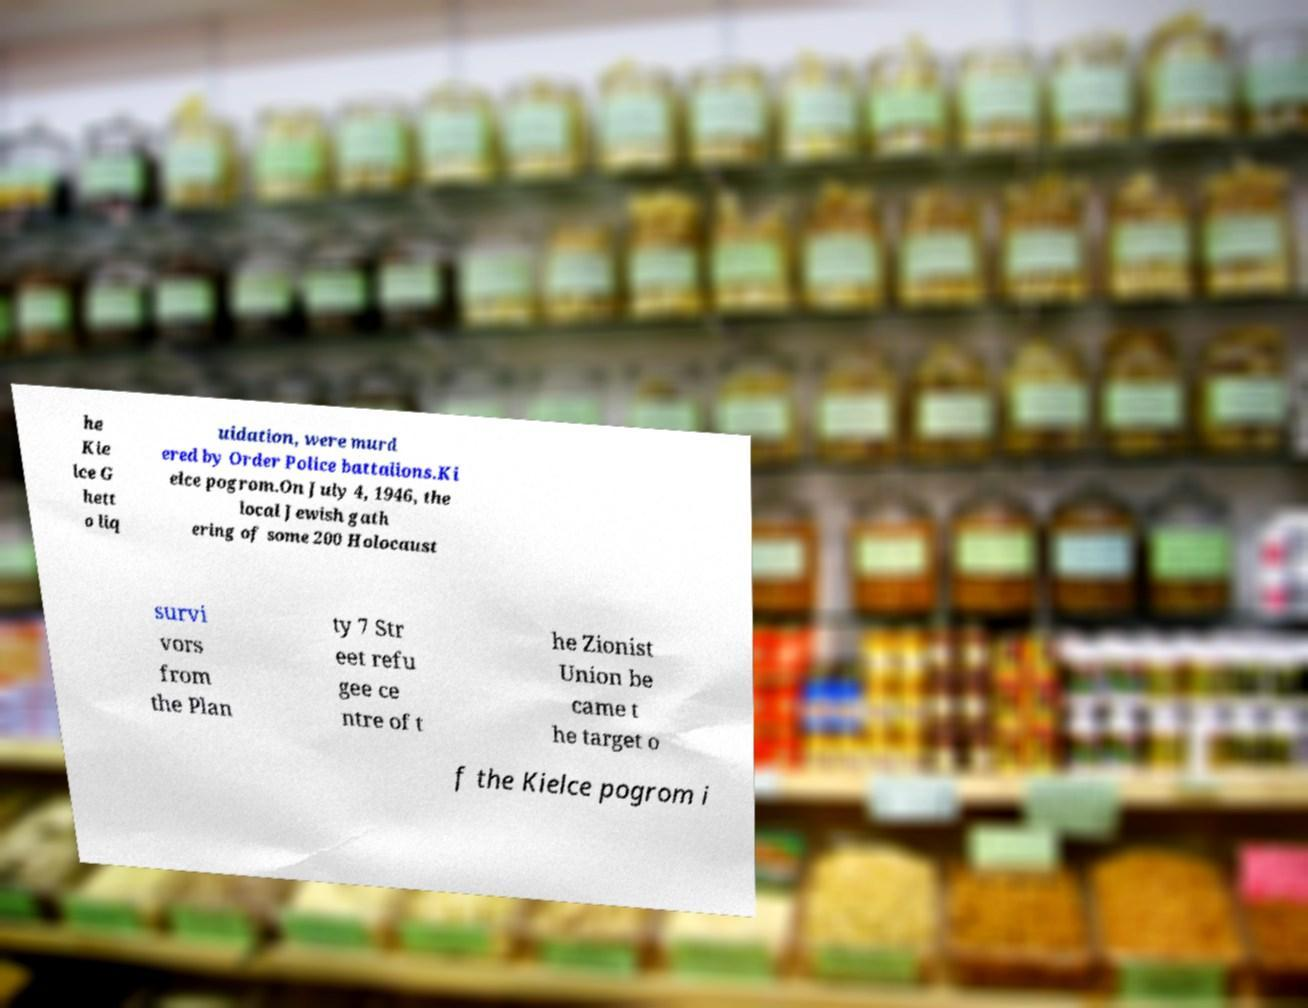What messages or text are displayed in this image? I need them in a readable, typed format. he Kie lce G hett o liq uidation, were murd ered by Order Police battalions.Ki elce pogrom.On July 4, 1946, the local Jewish gath ering of some 200 Holocaust survi vors from the Plan ty 7 Str eet refu gee ce ntre of t he Zionist Union be came t he target o f the Kielce pogrom i 